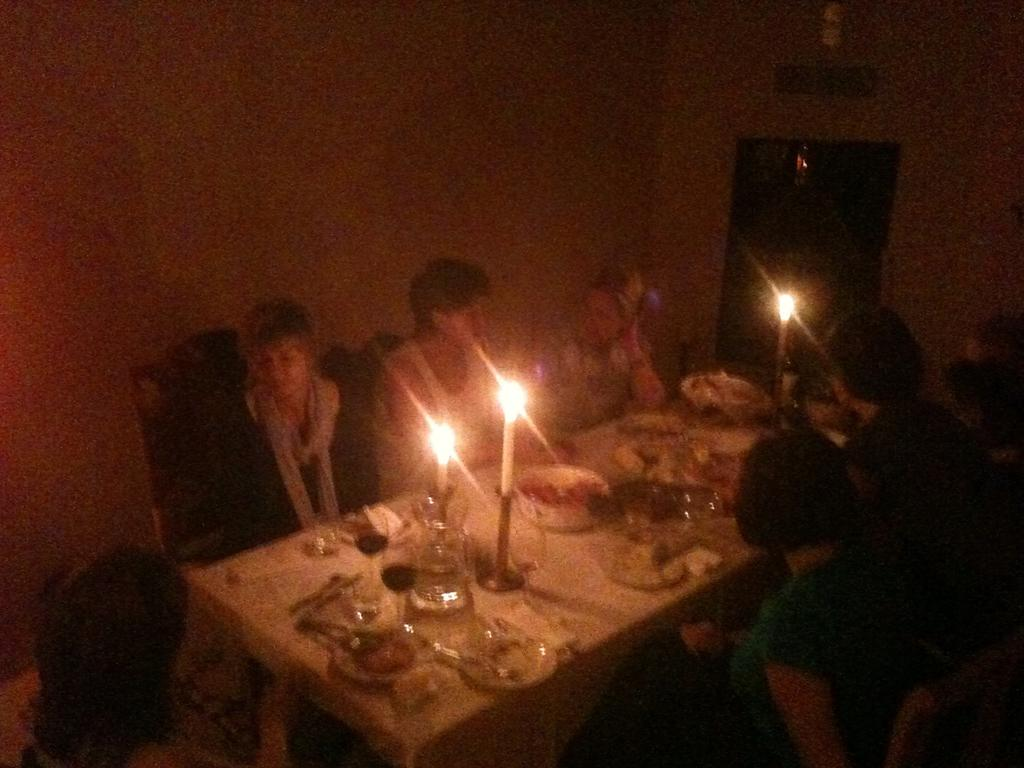What type of objects can be seen in the image? There are candles, plates, and spoons in the image. Where are these objects located? The objects are on a dining table. Are there any people present in the image? Yes, there are people sitting on chairs in the image. What can be seen in the background of the image? There is a wall visible in the image. What type of vest is the plate wearing in the image? There is no vest present in the image, as plates are inanimate objects and cannot wear clothing. 